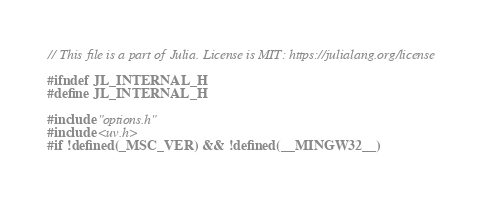Convert code to text. <code><loc_0><loc_0><loc_500><loc_500><_C_>// This file is a part of Julia. License is MIT: https://julialang.org/license

#ifndef JL_INTERNAL_H
#define JL_INTERNAL_H

#include "options.h"
#include <uv.h>
#if !defined(_MSC_VER) && !defined(__MINGW32__)</code> 